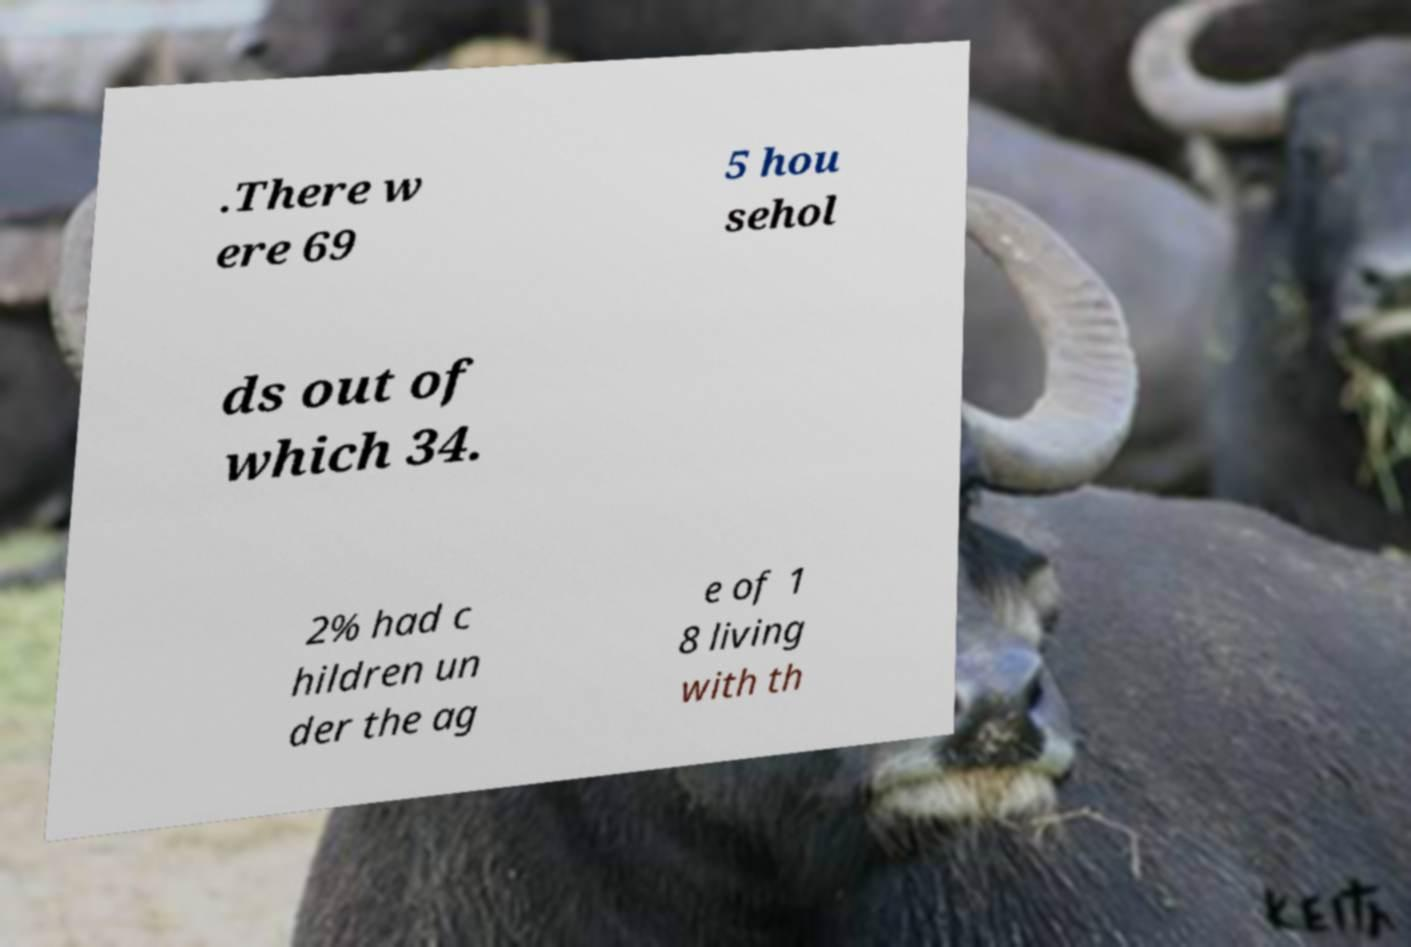Can you accurately transcribe the text from the provided image for me? .There w ere 69 5 hou sehol ds out of which 34. 2% had c hildren un der the ag e of 1 8 living with th 